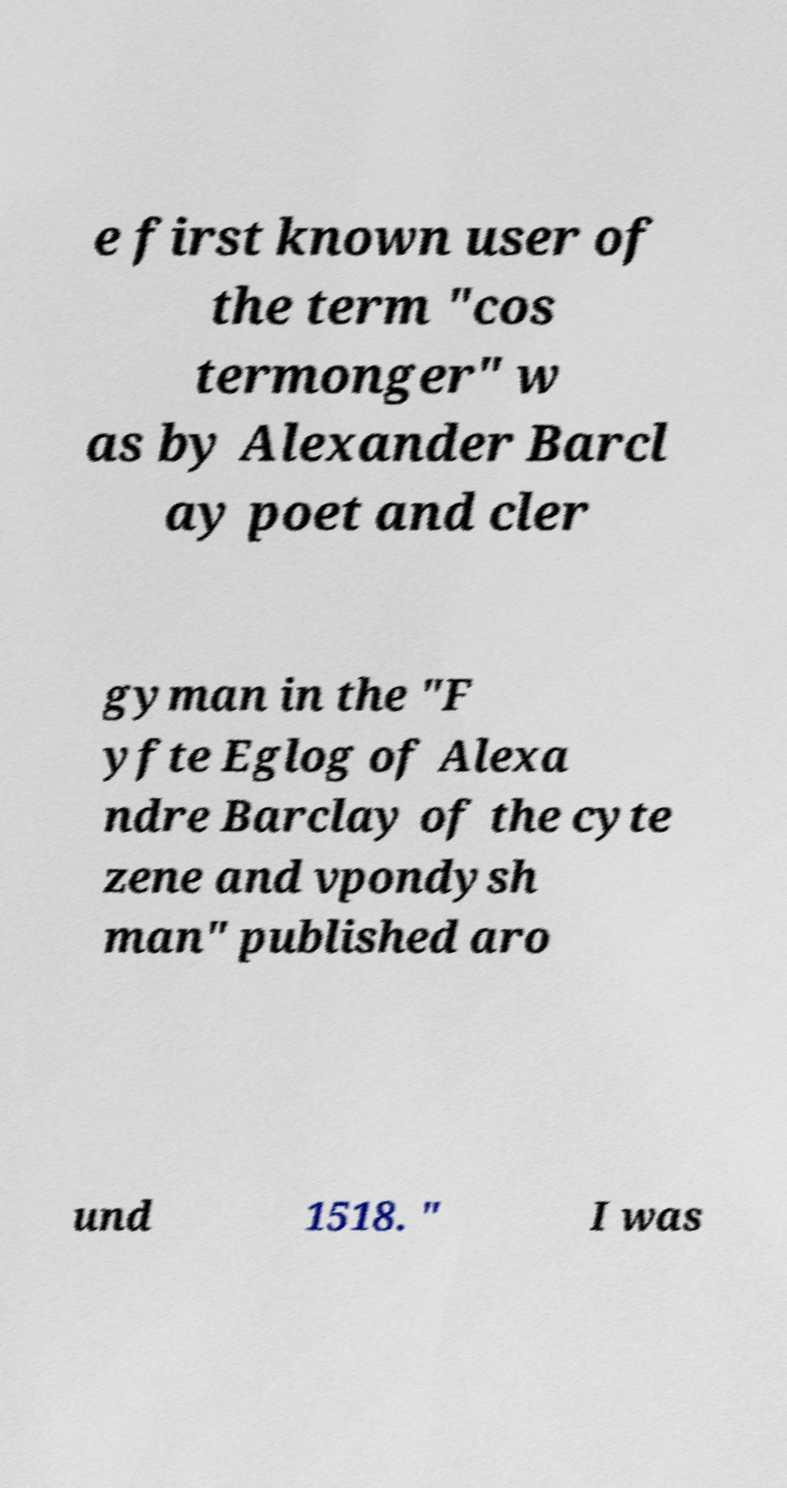Can you read and provide the text displayed in the image?This photo seems to have some interesting text. Can you extract and type it out for me? e first known user of the term "cos termonger" w as by Alexander Barcl ay poet and cler gyman in the "F yfte Eglog of Alexa ndre Barclay of the cyte zene and vpondysh man" published aro und 1518. " I was 